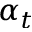Convert formula to latex. <formula><loc_0><loc_0><loc_500><loc_500>\alpha _ { t }</formula> 